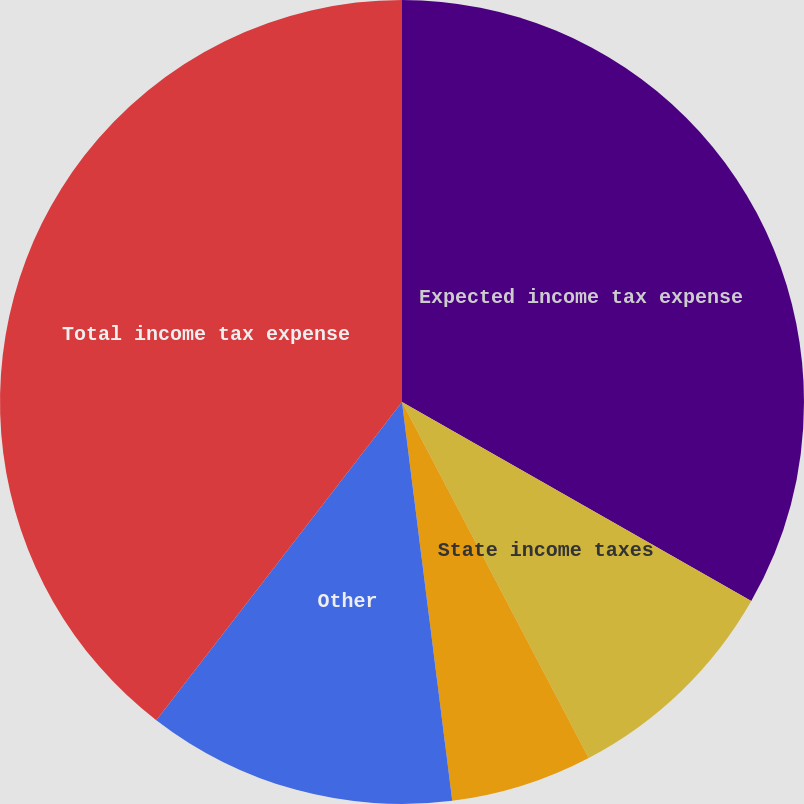Convert chart. <chart><loc_0><loc_0><loc_500><loc_500><pie_chart><fcel>Expected income tax expense<fcel>State income taxes<fcel>Taxation on Canadian<fcel>Other<fcel>Total income tax expense<nl><fcel>33.24%<fcel>9.07%<fcel>5.69%<fcel>12.46%<fcel>39.53%<nl></chart> 